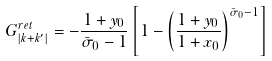Convert formula to latex. <formula><loc_0><loc_0><loc_500><loc_500>G _ { \left | k + k ^ { \prime } \right | } ^ { r e t } = - \frac { 1 + y _ { 0 } } { \bar { \sigma } _ { 0 } - 1 } \left [ 1 - \left ( \frac { 1 + y _ { 0 } } { 1 + x _ { 0 } } \right ) ^ { \bar { \sigma } _ { 0 } - 1 } \right ]</formula> 